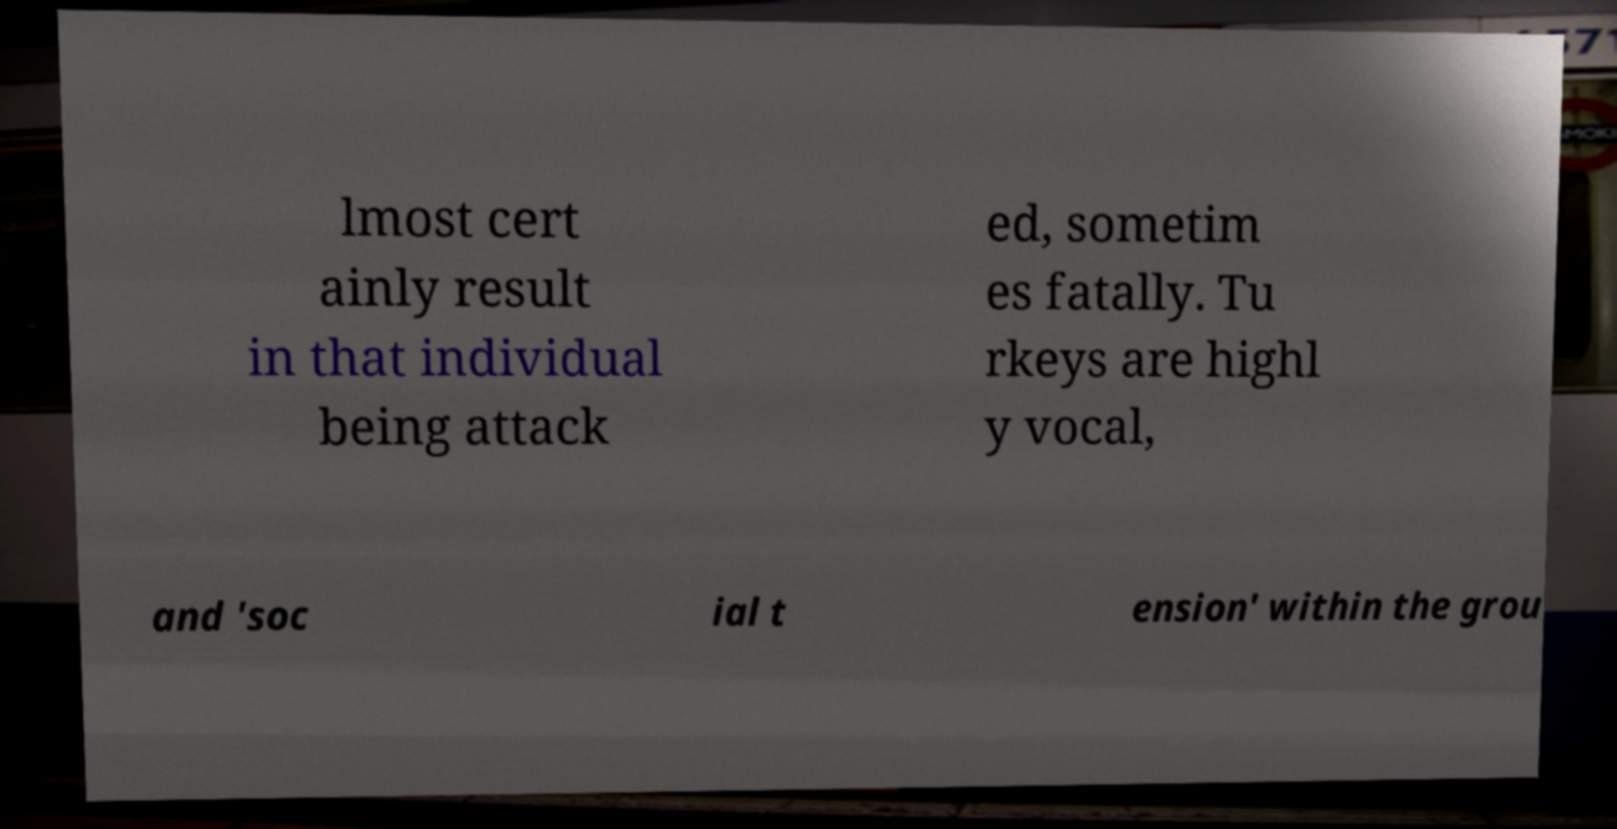Could you extract and type out the text from this image? lmost cert ainly result in that individual being attack ed, sometim es fatally. Tu rkeys are highl y vocal, and 'soc ial t ension' within the grou 